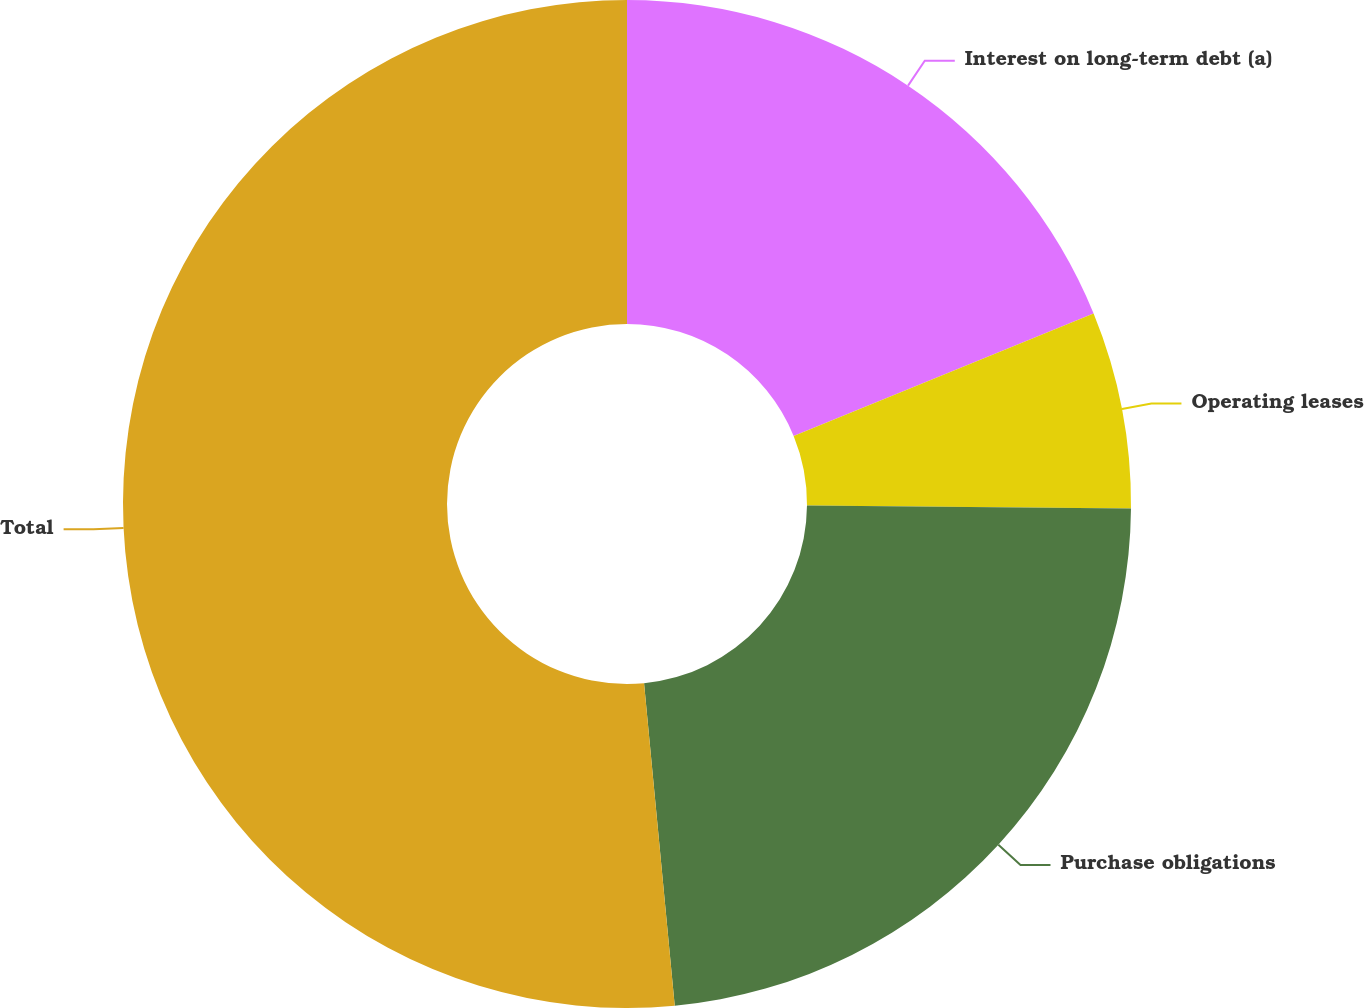Convert chart. <chart><loc_0><loc_0><loc_500><loc_500><pie_chart><fcel>Interest on long-term debt (a)<fcel>Operating leases<fcel>Purchase obligations<fcel>Total<nl><fcel>18.83%<fcel>6.31%<fcel>23.35%<fcel>51.51%<nl></chart> 